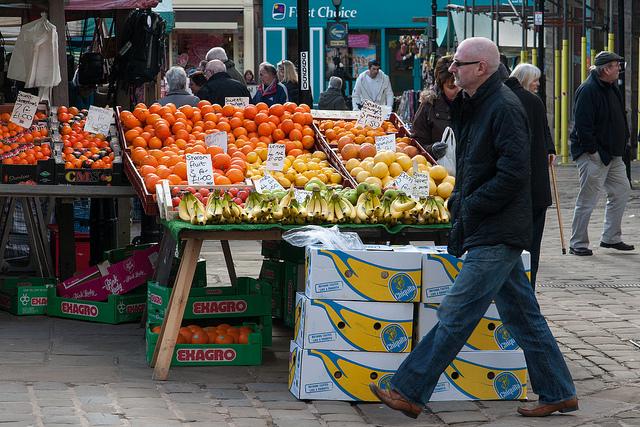How many different fruits can be seen?
Concise answer only. 4. How many green bananas are in this storefront?
Short answer required. 0. What fruit is closest to the camera?
Short answer required. Banana. How many watermelons are in this picture?
Answer briefly. 0. Is the guy on the right wearing a hat?
Quick response, please. Yes. Is there a fruit known as 'a bit of sunshine' in this photo?
Keep it brief. Yes. Are the men wearing pants?
Short answer required. Yes. How many people are in front of the fruit stand?
Concise answer only. 1. 